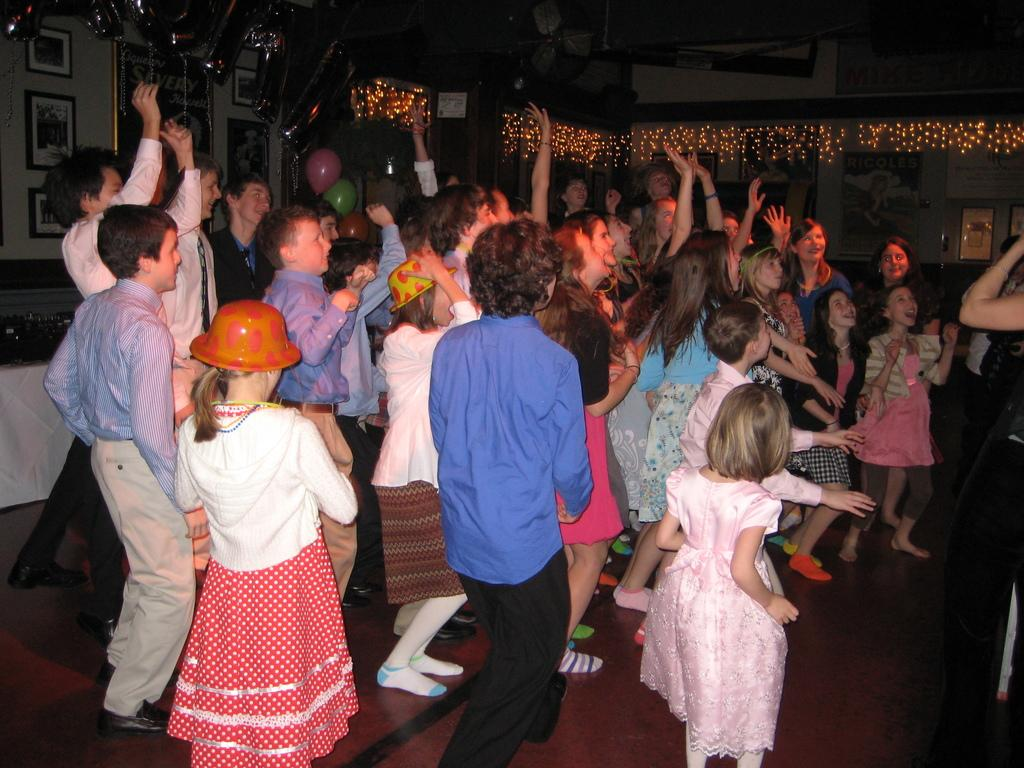How many children are present in the image? There are many children in the image. What are some of the children wearing? Some of the children are wearing hats. What can be seen on the walls in the image? There are photo frames on the walls. What decorative items are present in the image? There are balloons in the image. What type of lighting is visible in the image? There are lights in the image. What scent can be detected in the image? There is no information about a scent in the image, as it focuses on visual elements such as the children, hats, photo frames, balloons, and lights. 